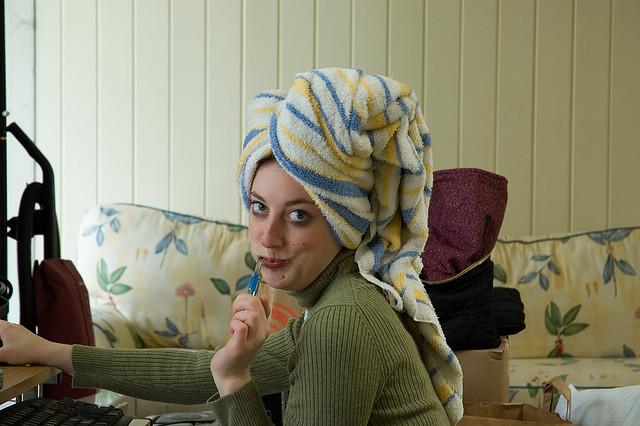Did the woman just wash her hair?
Keep it brief. Yes. Is the woman wearing a watch?
Concise answer only. No. Is the woman ready to leave the room?
Answer briefly. No. How many people are in the picture?
Concise answer only. 1. 